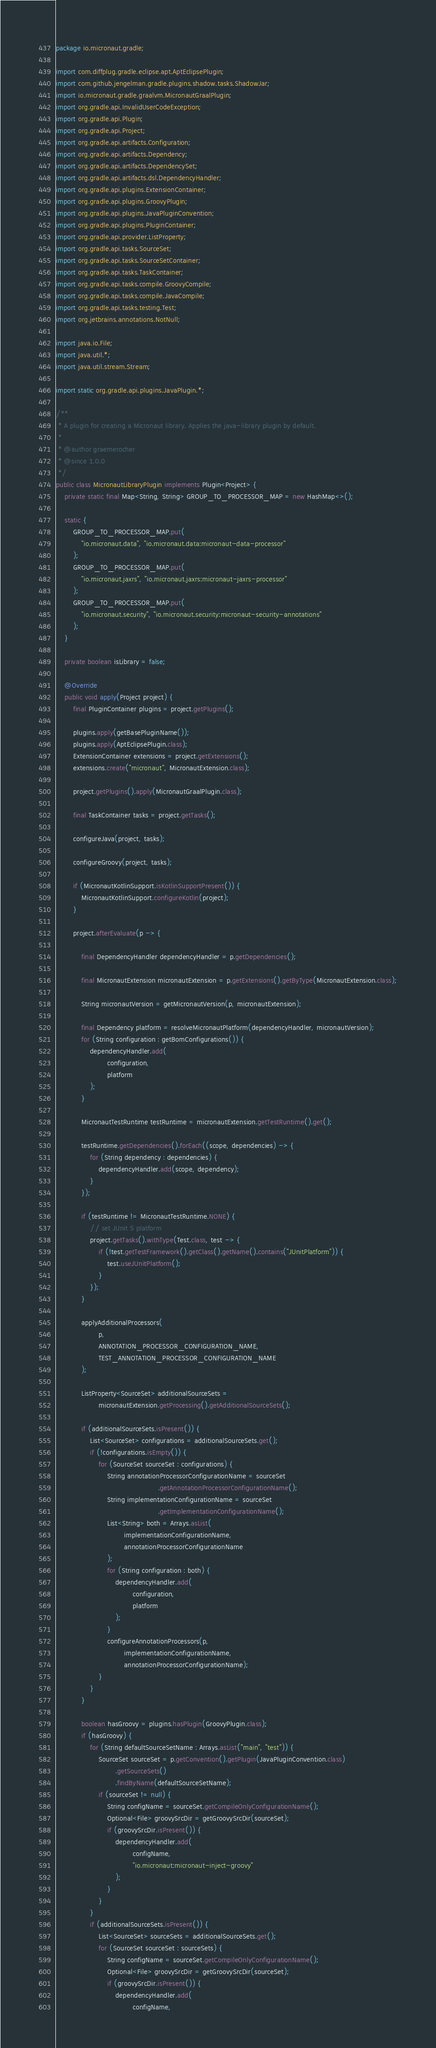Convert code to text. <code><loc_0><loc_0><loc_500><loc_500><_Java_>package io.micronaut.gradle;

import com.diffplug.gradle.eclipse.apt.AptEclipsePlugin;
import com.github.jengelman.gradle.plugins.shadow.tasks.ShadowJar;
import io.micronaut.gradle.graalvm.MicronautGraalPlugin;
import org.gradle.api.InvalidUserCodeException;
import org.gradle.api.Plugin;
import org.gradle.api.Project;
import org.gradle.api.artifacts.Configuration;
import org.gradle.api.artifacts.Dependency;
import org.gradle.api.artifacts.DependencySet;
import org.gradle.api.artifacts.dsl.DependencyHandler;
import org.gradle.api.plugins.ExtensionContainer;
import org.gradle.api.plugins.GroovyPlugin;
import org.gradle.api.plugins.JavaPluginConvention;
import org.gradle.api.plugins.PluginContainer;
import org.gradle.api.provider.ListProperty;
import org.gradle.api.tasks.SourceSet;
import org.gradle.api.tasks.SourceSetContainer;
import org.gradle.api.tasks.TaskContainer;
import org.gradle.api.tasks.compile.GroovyCompile;
import org.gradle.api.tasks.compile.JavaCompile;
import org.gradle.api.tasks.testing.Test;
import org.jetbrains.annotations.NotNull;

import java.io.File;
import java.util.*;
import java.util.stream.Stream;

import static org.gradle.api.plugins.JavaPlugin.*;

/**
 * A plugin for creating a Micronaut library. Applies the java-library plugin by default.
 *
 * @author graemerocher
 * @since 1.0.0
 */
public class MicronautLibraryPlugin implements Plugin<Project> {
    private static final Map<String, String> GROUP_TO_PROCESSOR_MAP = new HashMap<>();

    static {
        GROUP_TO_PROCESSOR_MAP.put(
            "io.micronaut.data", "io.micronaut.data:micronaut-data-processor"
        );
        GROUP_TO_PROCESSOR_MAP.put(
            "io.micronaut.jaxrs", "io.micronaut.jaxrs:micronaut-jaxrs-processor"
        );
        GROUP_TO_PROCESSOR_MAP.put(
            "io.micronaut.security", "io.micronaut.security:micronaut-security-annotations"
        );
    }

    private boolean isLibrary = false;

    @Override
    public void apply(Project project) {
        final PluginContainer plugins = project.getPlugins();

        plugins.apply(getBasePluginName());
        plugins.apply(AptEclipsePlugin.class);
        ExtensionContainer extensions = project.getExtensions();
        extensions.create("micronaut", MicronautExtension.class);

        project.getPlugins().apply(MicronautGraalPlugin.class);

        final TaskContainer tasks = project.getTasks();

        configureJava(project, tasks);

        configureGroovy(project, tasks);

        if (MicronautKotlinSupport.isKotlinSupportPresent()) {
            MicronautKotlinSupport.configureKotlin(project);
        }

        project.afterEvaluate(p -> {

            final DependencyHandler dependencyHandler = p.getDependencies();

            final MicronautExtension micronautExtension = p.getExtensions().getByType(MicronautExtension.class);

            String micronautVersion = getMicronautVersion(p, micronautExtension);

            final Dependency platform = resolveMicronautPlatform(dependencyHandler, micronautVersion);
            for (String configuration : getBomConfigurations()) {
                dependencyHandler.add(
                        configuration,
                        platform
                );
            }

            MicronautTestRuntime testRuntime = micronautExtension.getTestRuntime().get();

            testRuntime.getDependencies().forEach((scope, dependencies) -> {
                for (String dependency : dependencies) {
                    dependencyHandler.add(scope, dependency);
                }
            });

            if (testRuntime != MicronautTestRuntime.NONE) {
                // set JUnit 5 platform
                project.getTasks().withType(Test.class, test -> {
                    if (!test.getTestFramework().getClass().getName().contains("JUnitPlatform")) {
                        test.useJUnitPlatform();
                    }
                });
            }

            applyAdditionalProcessors(
                    p,
                    ANNOTATION_PROCESSOR_CONFIGURATION_NAME,
                    TEST_ANNOTATION_PROCESSOR_CONFIGURATION_NAME
            );

            ListProperty<SourceSet> additionalSourceSets =
                    micronautExtension.getProcessing().getAdditionalSourceSets();

            if (additionalSourceSets.isPresent()) {
                List<SourceSet> configurations = additionalSourceSets.get();
                if (!configurations.isEmpty()) {
                    for (SourceSet sourceSet : configurations) {
                        String annotationProcessorConfigurationName = sourceSet
                                                .getAnnotationProcessorConfigurationName();
                        String implementationConfigurationName = sourceSet
                                                .getImplementationConfigurationName();
                        List<String> both = Arrays.asList(
                                implementationConfigurationName,
                                annotationProcessorConfigurationName
                        );
                        for (String configuration : both) {
                            dependencyHandler.add(
                                    configuration,
                                    platform
                            );
                        }
                        configureAnnotationProcessors(p,
                                implementationConfigurationName,
                                annotationProcessorConfigurationName);
                    }
                }
            }

            boolean hasGroovy = plugins.hasPlugin(GroovyPlugin.class);
            if (hasGroovy) {
                for (String defaultSourceSetName : Arrays.asList("main", "test")) {
                    SourceSet sourceSet = p.getConvention().getPlugin(JavaPluginConvention.class)
                            .getSourceSets()
                            .findByName(defaultSourceSetName);
                    if (sourceSet != null) {
                        String configName = sourceSet.getCompileOnlyConfigurationName();
                        Optional<File> groovySrcDir = getGroovySrcDir(sourceSet);
                        if (groovySrcDir.isPresent()) {
                            dependencyHandler.add(
                                    configName,
                                    "io.micronaut:micronaut-inject-groovy"
                            );
                        }
                    }
                }
                if (additionalSourceSets.isPresent()) {
                    List<SourceSet> sourceSets = additionalSourceSets.get();
                    for (SourceSet sourceSet : sourceSets) {
                        String configName = sourceSet.getCompileOnlyConfigurationName();
                        Optional<File> groovySrcDir = getGroovySrcDir(sourceSet);
                        if (groovySrcDir.isPresent()) {
                            dependencyHandler.add(
                                    configName,</code> 